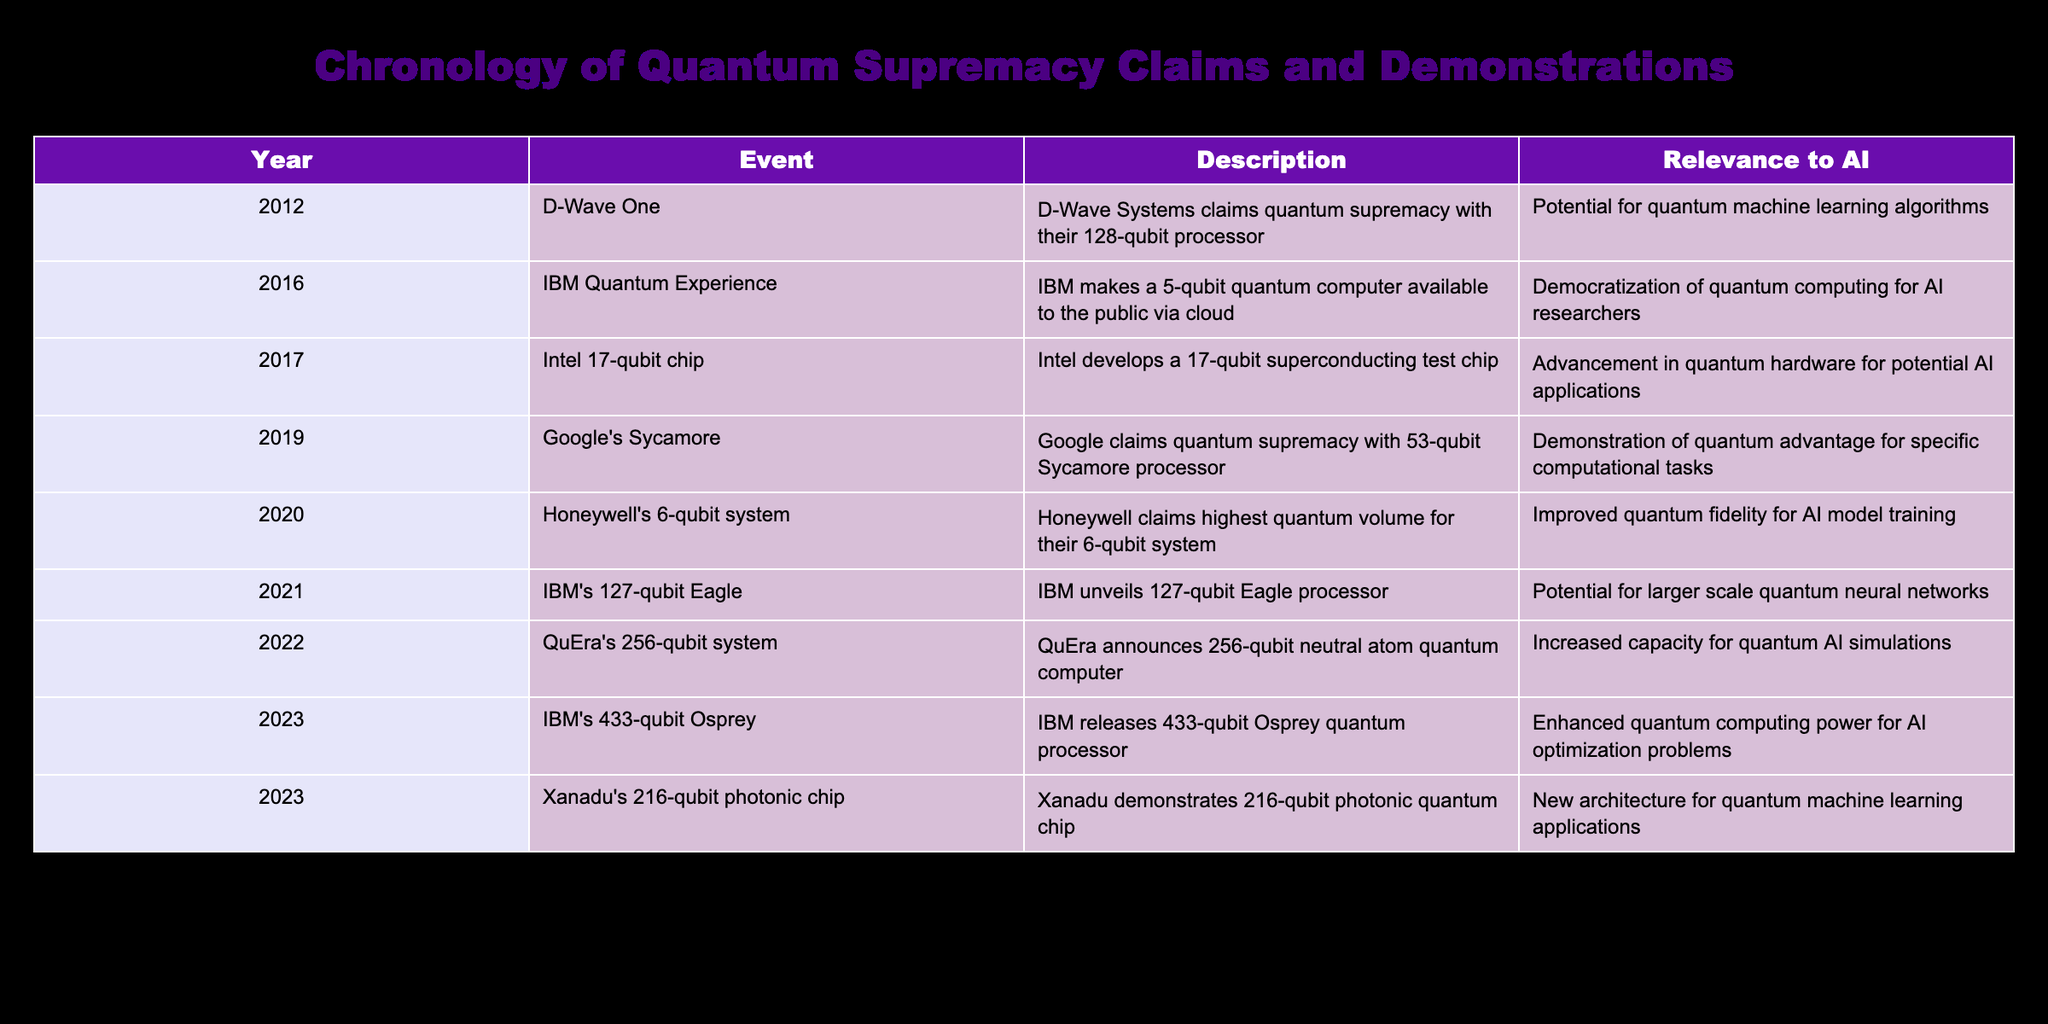What year did Google claim quantum supremacy? In the table, the row corresponding to Google shows that they claimed quantum supremacy in 2019.
Answer: 2019 Which quantum computer had the highest number of qubits mentioned in the table? The row for IBM's 433-qubit Osprey quantum processor in 2023 indicates that it has the highest number of qubits listed among the events.
Answer: 433 How many qubits did IBM's Eagle processor have compared to Intel's 17-qubit chip? IBM's Eagle processor had 127 qubits while Intel's chip had 17 qubits. The difference is 127 - 17 = 110 qubits.
Answer: 110 Did any companies claim quantum supremacy in the year 2020? Referring to the table, there are no claims of quantum supremacy noted for the year 2020, only a metrics claim of quantum volume by Honeywell.
Answer: No What is the total number of qubits in QuEra's 256-qubit system and IBM's 433-qubit Osprey? Adding the number of qubits from the two processors gives us 256 + 433 = 689 qubits in total.
Answer: 689 Which event in 2022 increased capacity for quantum AI simulations? QuEra's 256-qubit system announcement in 2022 is specifically stated to have increased the capacity for quantum AI simulations.
Answer: QuEra's 256-qubit system Was the IBM Quantum Experience relevant to the democratization of quantum computing for AI researchers? The description in the table for the IBM Quantum Experience states that it was indeed relevant for democratizing access for AI researchers.
Answer: Yes How many events were recorded before Google's Sycamore claimed quantum supremacy? Reviewing the years before 2019, we count the events in 2012, 2016, and 2017, which gives us a total of 3 preceding events.
Answer: 3 Which quantum processor was released in 2023 by Xanadu? The table indicates that Xanadu demonstrated a 216-qubit photonic quantum chip in 2023.
Answer: 216-qubit photonic chip 